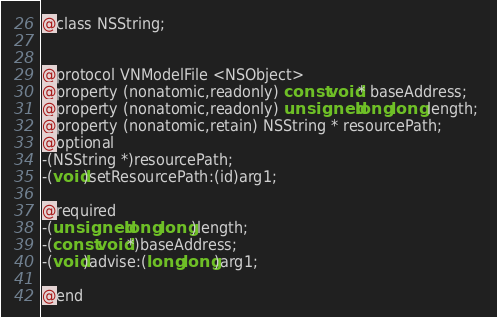Convert code to text. <code><loc_0><loc_0><loc_500><loc_500><_C_>
@class NSString;


@protocol VNModelFile <NSObject>
@property (nonatomic,readonly) const void* baseAddress; 
@property (nonatomic,readonly) unsigned long long length; 
@property (nonatomic,retain) NSString * resourcePath; 
@optional
-(NSString *)resourcePath;
-(void)setResourcePath:(id)arg1;

@required
-(unsigned long long)length;
-(const void*)baseAddress;
-(void)advise:(long long)arg1;

@end

</code> 